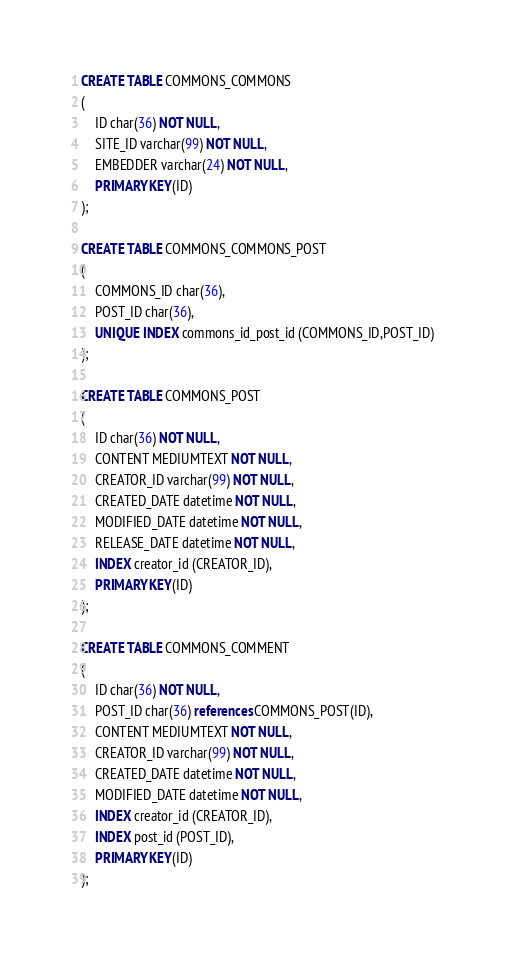Convert code to text. <code><loc_0><loc_0><loc_500><loc_500><_SQL_>CREATE TABLE COMMONS_COMMONS
(
    ID char(36) NOT NULL,
    SITE_ID varchar(99) NOT NULL,
    EMBEDDER varchar(24) NOT NULL,
    PRIMARY KEY(ID)
);

CREATE TABLE COMMONS_COMMONS_POST
(
    COMMONS_ID char(36),
    POST_ID char(36),
    UNIQUE INDEX commons_id_post_id (COMMONS_ID,POST_ID)
);

CREATE TABLE COMMONS_POST
(
    ID char(36) NOT NULL,
    CONTENT MEDIUMTEXT NOT NULL,
    CREATOR_ID varchar(99) NOT NULL,
    CREATED_DATE datetime NOT NULL,
    MODIFIED_DATE datetime NOT NULL,
    RELEASE_DATE datetime NOT NULL,
    INDEX creator_id (CREATOR_ID),
    PRIMARY KEY(ID)
);

CREATE TABLE COMMONS_COMMENT
(
    ID char(36) NOT NULL,
    POST_ID char(36) references COMMONS_POST(ID),
    CONTENT MEDIUMTEXT NOT NULL,
    CREATOR_ID varchar(99) NOT NULL,
    CREATED_DATE datetime NOT NULL,
    MODIFIED_DATE datetime NOT NULL,
    INDEX creator_id (CREATOR_ID),
    INDEX post_id (POST_ID),
    PRIMARY KEY(ID)
);
</code> 